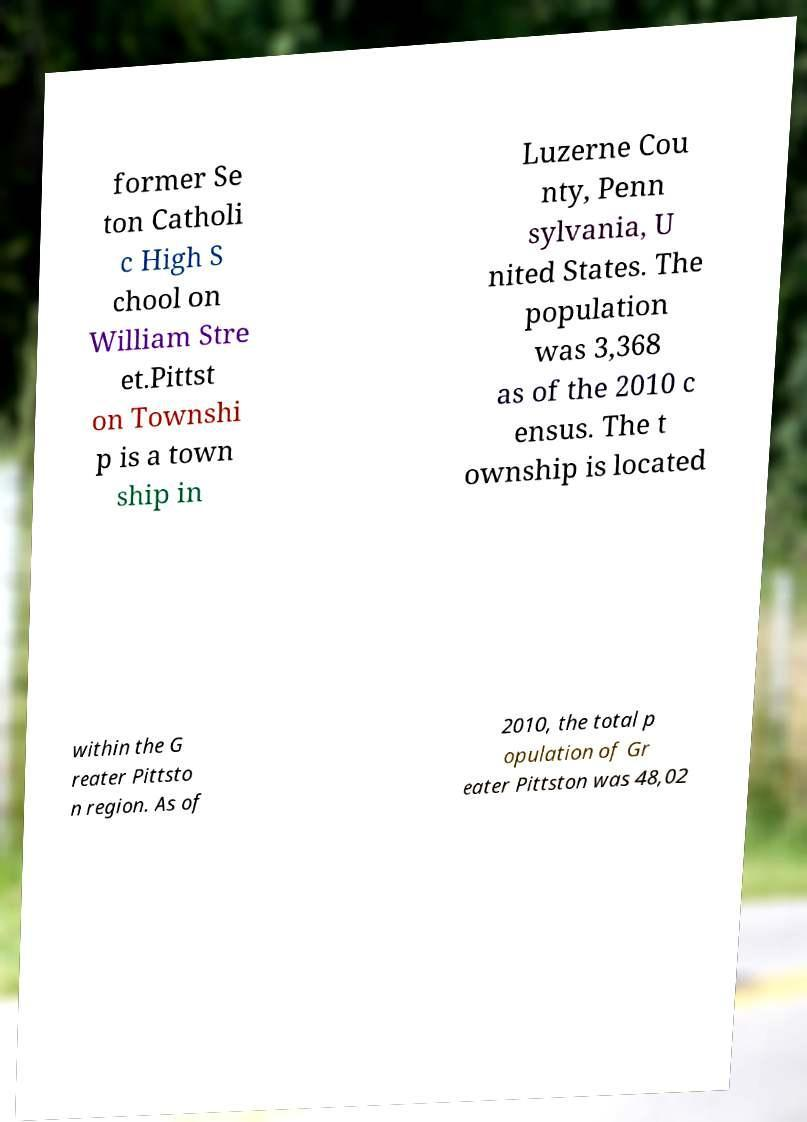For documentation purposes, I need the text within this image transcribed. Could you provide that? former Se ton Catholi c High S chool on William Stre et.Pittst on Townshi p is a town ship in Luzerne Cou nty, Penn sylvania, U nited States. The population was 3,368 as of the 2010 c ensus. The t ownship is located within the G reater Pittsto n region. As of 2010, the total p opulation of Gr eater Pittston was 48,02 